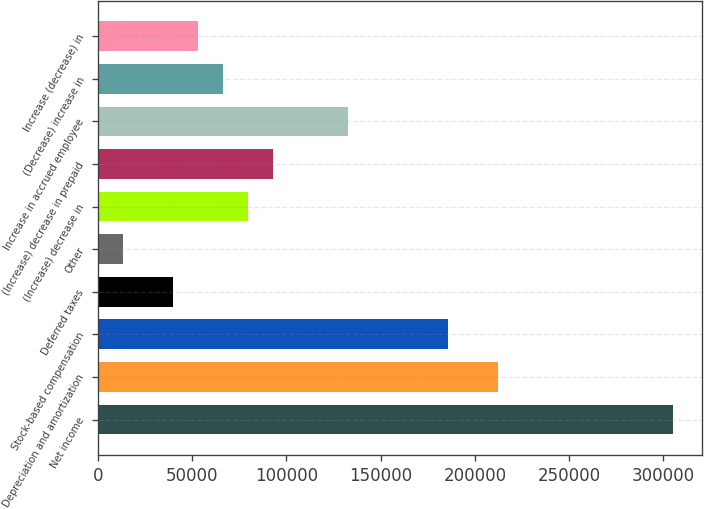Convert chart to OTSL. <chart><loc_0><loc_0><loc_500><loc_500><bar_chart><fcel>Net income<fcel>Depreciation and amortization<fcel>Stock-based compensation<fcel>Deferred taxes<fcel>Other<fcel>(Increase) decrease in<fcel>(Increase) decrease in prepaid<fcel>Increase in accrued employee<fcel>(Decrease) increase in<fcel>Increase (decrease) in<nl><fcel>305166<fcel>212295<fcel>185760<fcel>39819.9<fcel>13285.3<fcel>79621.8<fcel>92889.1<fcel>132691<fcel>66354.5<fcel>53087.2<nl></chart> 